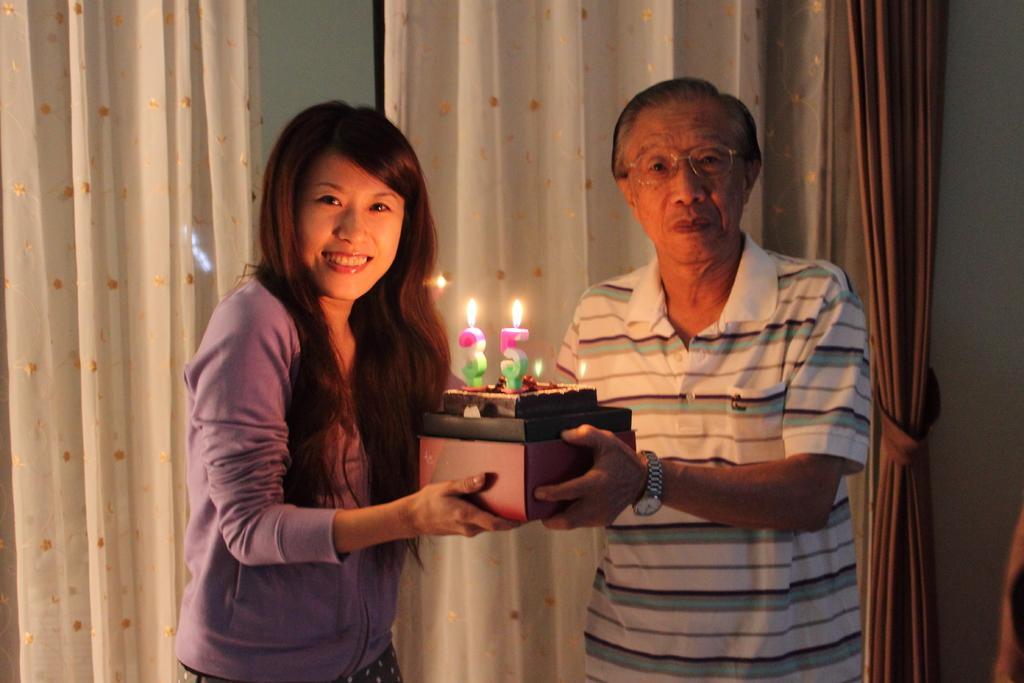Can you describe this image briefly? In the center of the image we can see two persons are holding a box. On box we can see a cake and candles. In the background of the image we can see the curtains and wall. 